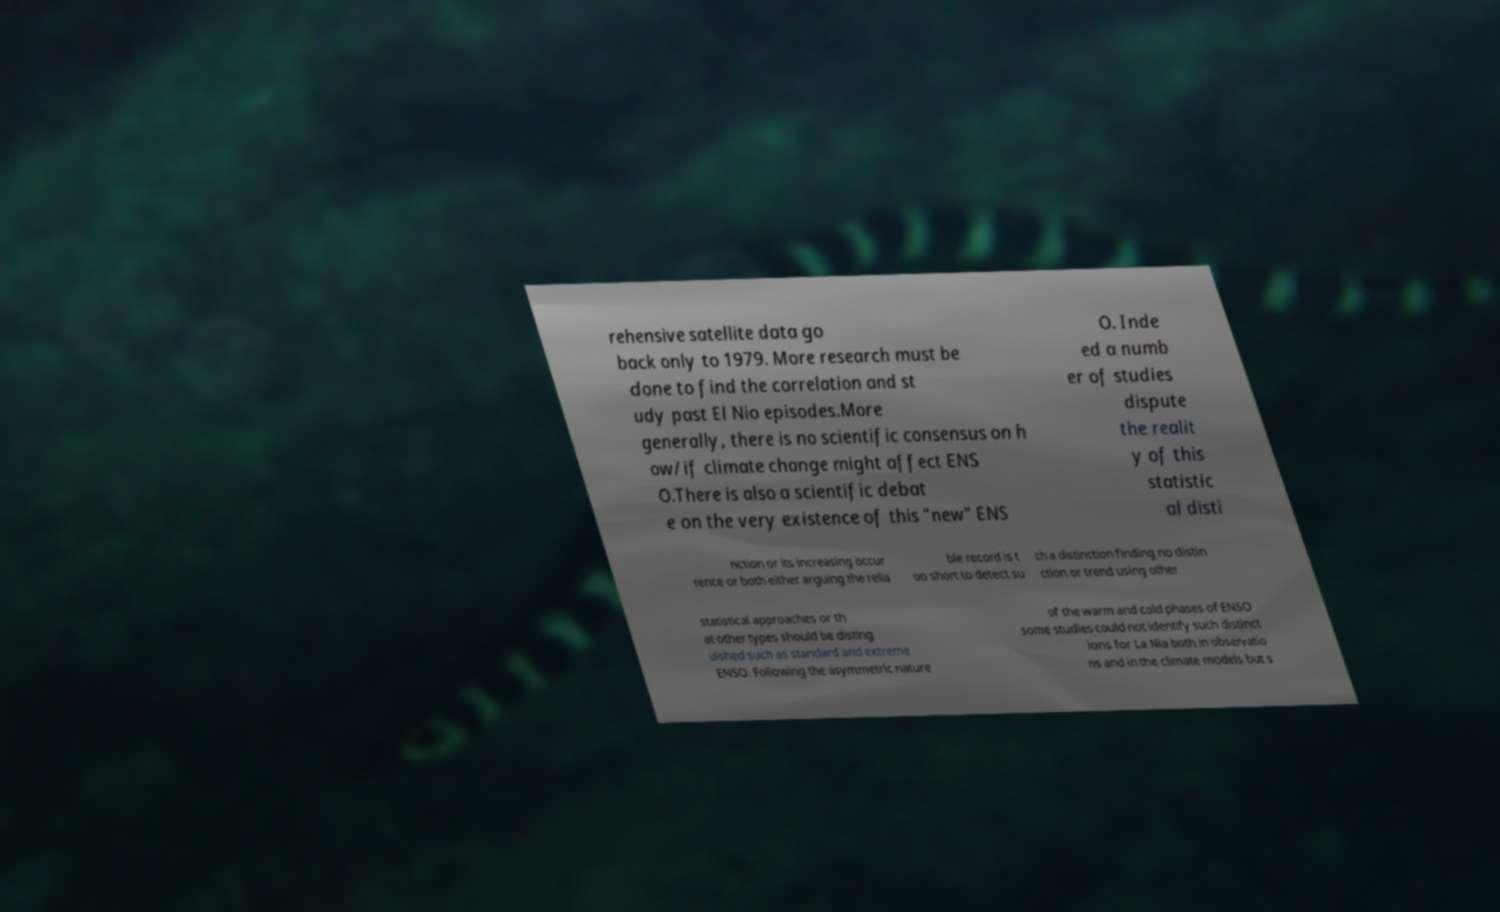What messages or text are displayed in this image? I need them in a readable, typed format. rehensive satellite data go back only to 1979. More research must be done to find the correlation and st udy past El Nio episodes.More generally, there is no scientific consensus on h ow/if climate change might affect ENS O.There is also a scientific debat e on the very existence of this "new" ENS O. Inde ed a numb er of studies dispute the realit y of this statistic al disti nction or its increasing occur rence or both either arguing the relia ble record is t oo short to detect su ch a distinction finding no distin ction or trend using other statistical approaches or th at other types should be disting uished such as standard and extreme ENSO. Following the asymmetric nature of the warm and cold phases of ENSO some studies could not identify such distinct ions for La Nia both in observatio ns and in the climate models but s 